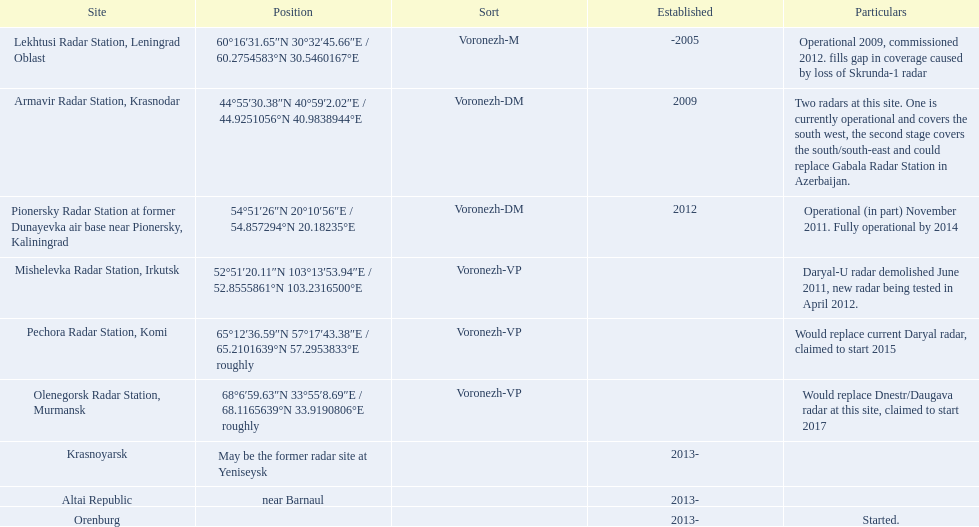Where is each radar? Lekhtusi Radar Station, Leningrad Oblast, Armavir Radar Station, Krasnodar, Pionersky Radar Station at former Dunayevka air base near Pionersky, Kaliningrad, Mishelevka Radar Station, Irkutsk, Pechora Radar Station, Komi, Olenegorsk Radar Station, Murmansk, Krasnoyarsk, Altai Republic, Orenburg. What are the details of each radar? Operational 2009, commissioned 2012. fills gap in coverage caused by loss of Skrunda-1 radar, Two radars at this site. One is currently operational and covers the south west, the second stage covers the south/south-east and could replace Gabala Radar Station in Azerbaijan., Operational (in part) November 2011. Fully operational by 2014, Daryal-U radar demolished June 2011, new radar being tested in April 2012., Would replace current Daryal radar, claimed to start 2015, Would replace Dnestr/Daugava radar at this site, claimed to start 2017, , , Started. Which radar is detailed to start in 2015? Pechora Radar Station, Komi. 